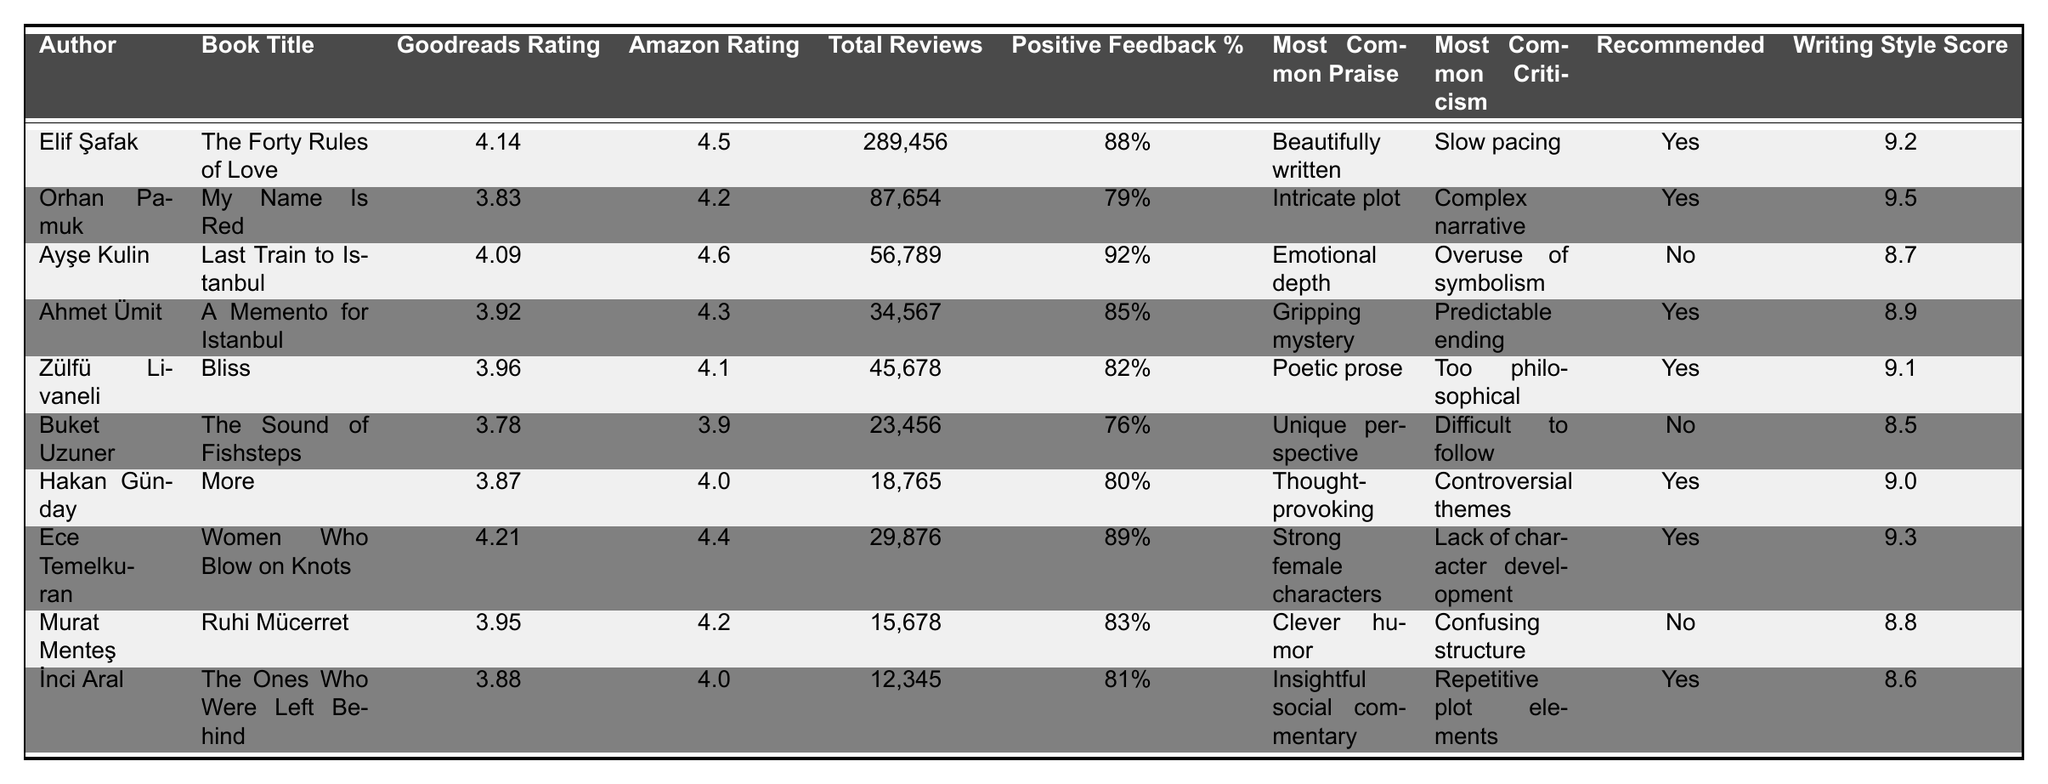What is the highest Goodreads rating among the listed authors? By examining the Goodreads ratings for each author in the table, the highest rating is 4.21 for Ece Temelkuran.
Answer: 4.21 Which author has the most total reviews? Looking at the Total Reviews column, Elif Şafak has the highest total reviews at 289,456.
Answer: Elif Şafak What is the average Amazon rating for all the authors? To find the average, sum all the Amazon ratings: (4.5 + 4.2 + 4.6 + 4.3 + 4.1 + 3.9 + 4.0 + 4.4 + 4.2 + 4.0) = 43.8, then divide by the number of authors (10): 43.8 / 10 = 4.38.
Answer: 4.38 Does Ayşe Kulin have positive feedback percentage greater than 90%? The Positive Feedback Percentage for Ayşe Kulin is 92%, which is greater than 90%.
Answer: Yes Which books are recommended for aspiring writers? The table lists authors whose books are recommended for aspiring writers, indicated by "Yes". These authors are: Elif Şafak, Orhan Pamuk, Ahmet Ümit, Zülfü Livaneli, Hakan Günday, Ece Temelkuran, and İnci Aral.
Answer: 7 authors What is the writing style score of Buket Uzuner? Directly refer to the Writing Style Score for Buket Uzuner in the table, which shows a score of 8.5.
Answer: 8.5 What is the most common criticism for Zülfü Livaneli's book? The table indicates that the most common criticism for Zülfü Livaneli's book "Bliss" is "Too philosophical."
Answer: Too philosophical How many authors have a Positive Feedback Percentage of 80% or more? By reviewing the Positive Feedback Percentage column, the authors who meet this criteria are Elif Şafak, Ayşe Kulin, Ahmet Ümit, Zülfü Livaneli, Hakan Günday, Ece Temelkuran, Murat Menteş, and İnci Aral, totaling 8 authors.
Answer: 8 authors Which author's book has the highest percentage of positive feedback? The author with the highest positive feedback percentage is Ayşe Kulin, with 92%.
Answer: Ayşe Kulin Is there a book that has both a Goodreads rating and Amazon rating below 4? Review the table for both ratings; the lowest ratings are for Buket Uzuner's book at 3.78 (Goodreads) and 3.9 (Amazon), both of which are not below 4.
Answer: No 